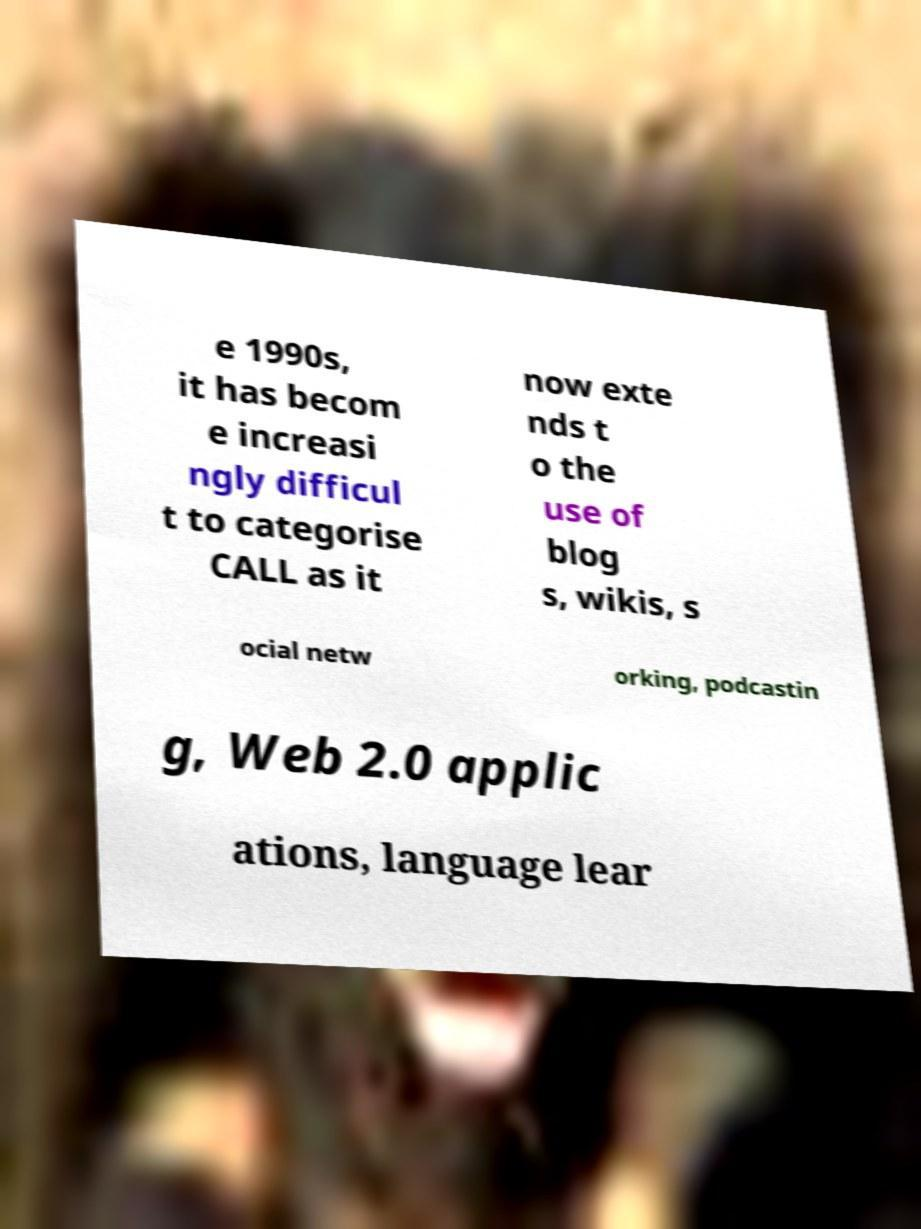Can you explain the context of this document based on the image? While the details are incomplete, the document is likely discussing the evolution and broadening scope of Computer-Assisted Language Learning (CALL). This field has expanded from structured computer programs to include interactive and social elements like blogs, wikis, social networking platforms, podcasts, and Web 2.0 applications, all of which now play a part in language learning and teaching. 